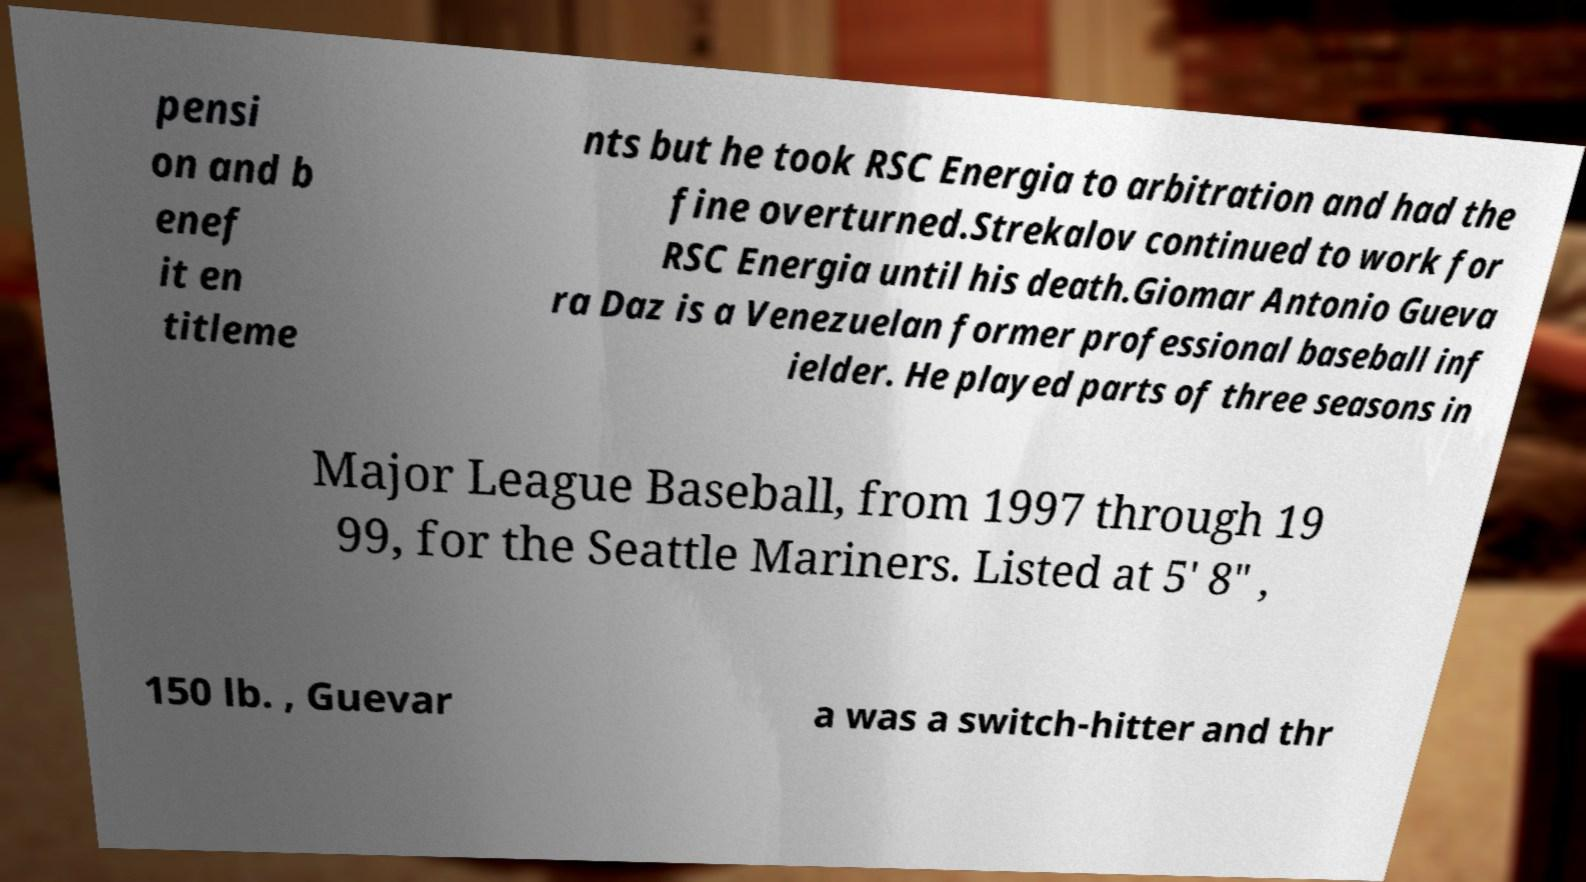Could you assist in decoding the text presented in this image and type it out clearly? pensi on and b enef it en titleme nts but he took RSC Energia to arbitration and had the fine overturned.Strekalov continued to work for RSC Energia until his death.Giomar Antonio Gueva ra Daz is a Venezuelan former professional baseball inf ielder. He played parts of three seasons in Major League Baseball, from 1997 through 19 99, for the Seattle Mariners. Listed at 5' 8" , 150 lb. , Guevar a was a switch-hitter and thr 